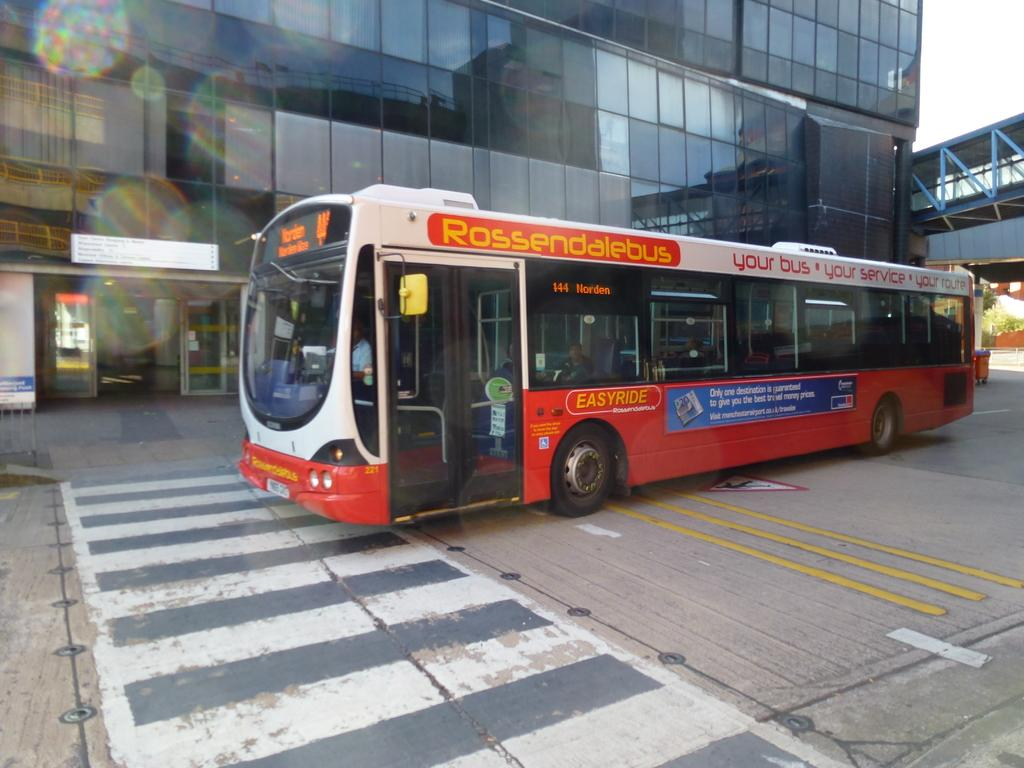<image>
Give a short and clear explanation of the subsequent image. A bus on the street that has the word easyride on it 